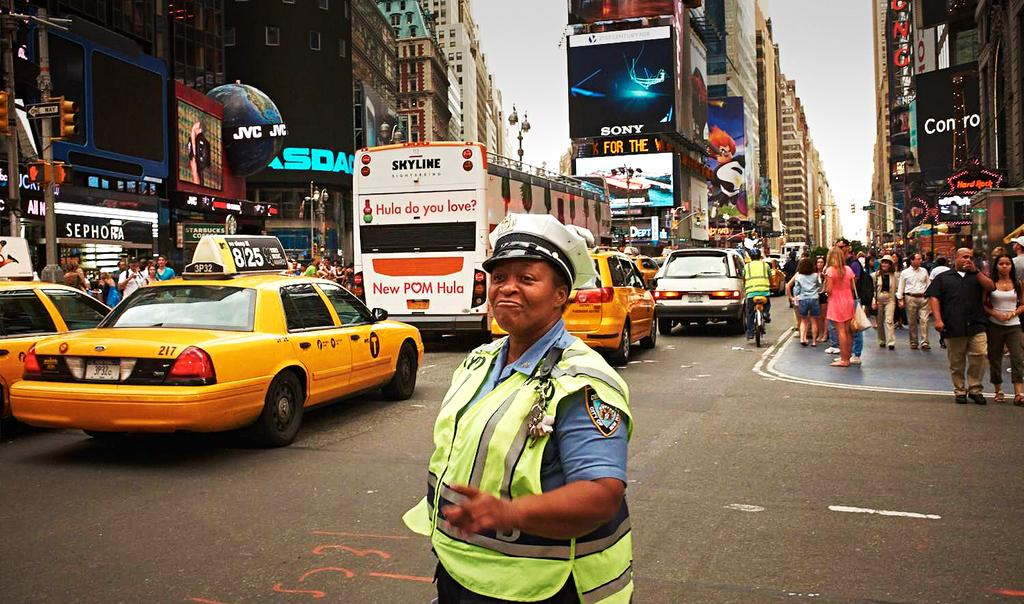<image>
Render a clear and concise summary of the photo. A woman directs traffic on a busy street filled with cars and pedestrians, in front of an advertismeent for Sony and Conro. 